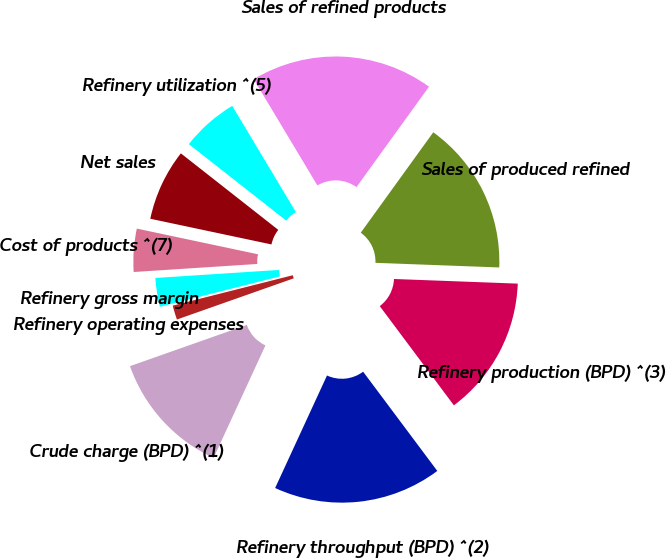<chart> <loc_0><loc_0><loc_500><loc_500><pie_chart><fcel>Crude charge (BPD) ^(1)<fcel>Refinery throughput (BPD) ^(2)<fcel>Refinery production (BPD) ^(3)<fcel>Sales of produced refined<fcel>Sales of refined products<fcel>Refinery utilization ^(5)<fcel>Net sales<fcel>Cost of products ^(7)<fcel>Refinery gross margin<fcel>Refinery operating expenses<nl><fcel>12.73%<fcel>17.09%<fcel>14.19%<fcel>15.64%<fcel>18.55%<fcel>5.81%<fcel>7.27%<fcel>4.36%<fcel>2.91%<fcel>1.45%<nl></chart> 